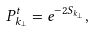Convert formula to latex. <formula><loc_0><loc_0><loc_500><loc_500>P _ { { k } _ { \perp } } ^ { t } = e ^ { - 2 S _ { { k } _ { \perp } } } ,</formula> 